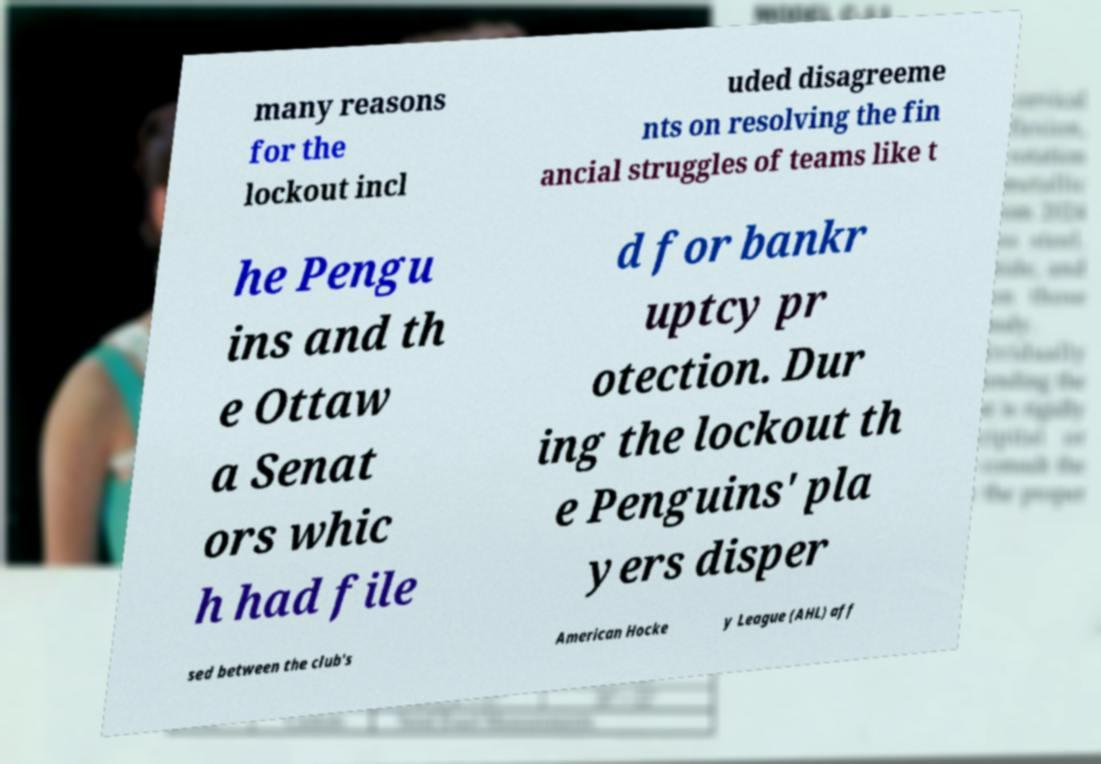There's text embedded in this image that I need extracted. Can you transcribe it verbatim? many reasons for the lockout incl uded disagreeme nts on resolving the fin ancial struggles of teams like t he Pengu ins and th e Ottaw a Senat ors whic h had file d for bankr uptcy pr otection. Dur ing the lockout th e Penguins' pla yers disper sed between the club's American Hocke y League (AHL) aff 